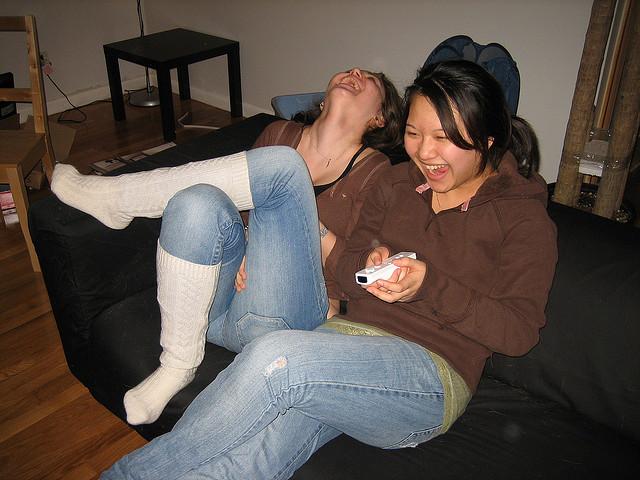Is the image in black and white?
Write a very short answer. No. What is in the woman's left hand?
Short answer required. Remote. What year was this picture taken?
Quick response, please. 2016. Are the two women lovers?
Short answer required. No. How many feet are visible?
Answer briefly. 2. Which hand is holding the knife?
Write a very short answer. Neither. Is there a chair next to the couch?
Quick response, please. Yes. Where is she sitting?
Be succinct. Couch. What symbol is on the woman's sleeve?
Concise answer only. None. What kind of shoes is the woman wearing?
Give a very brief answer. None. Is this girl upset?
Answer briefly. No. What it the girl holding?
Give a very brief answer. Remote. Is that a lifesaver on the back wall?
Concise answer only. No. Are there blinds in the image?
Short answer required. No. Could this be a nursery?
Write a very short answer. No. Are they both sitting on the couch?
Answer briefly. Yes. What is on the table by the woman?
Give a very brief answer. Nothing. What is the girl on the right holding?
Write a very short answer. Wii remote. Is the chair a rocking chair?
Short answer required. No. 